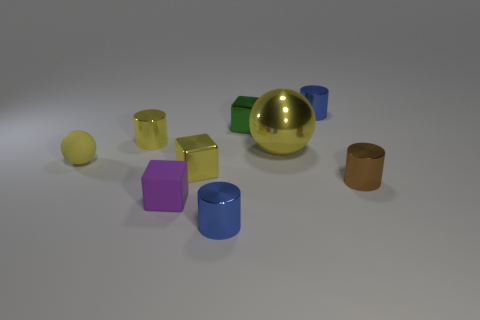Do the rubber thing that is behind the tiny rubber block and the small blue shiny object that is on the right side of the large ball have the same shape? No, the shapes are different. The object behind the tiny rubber block appears to be cylindrical, while the small blue shiny object on the right side of the large ball has a more complex, multifaceted shape. 